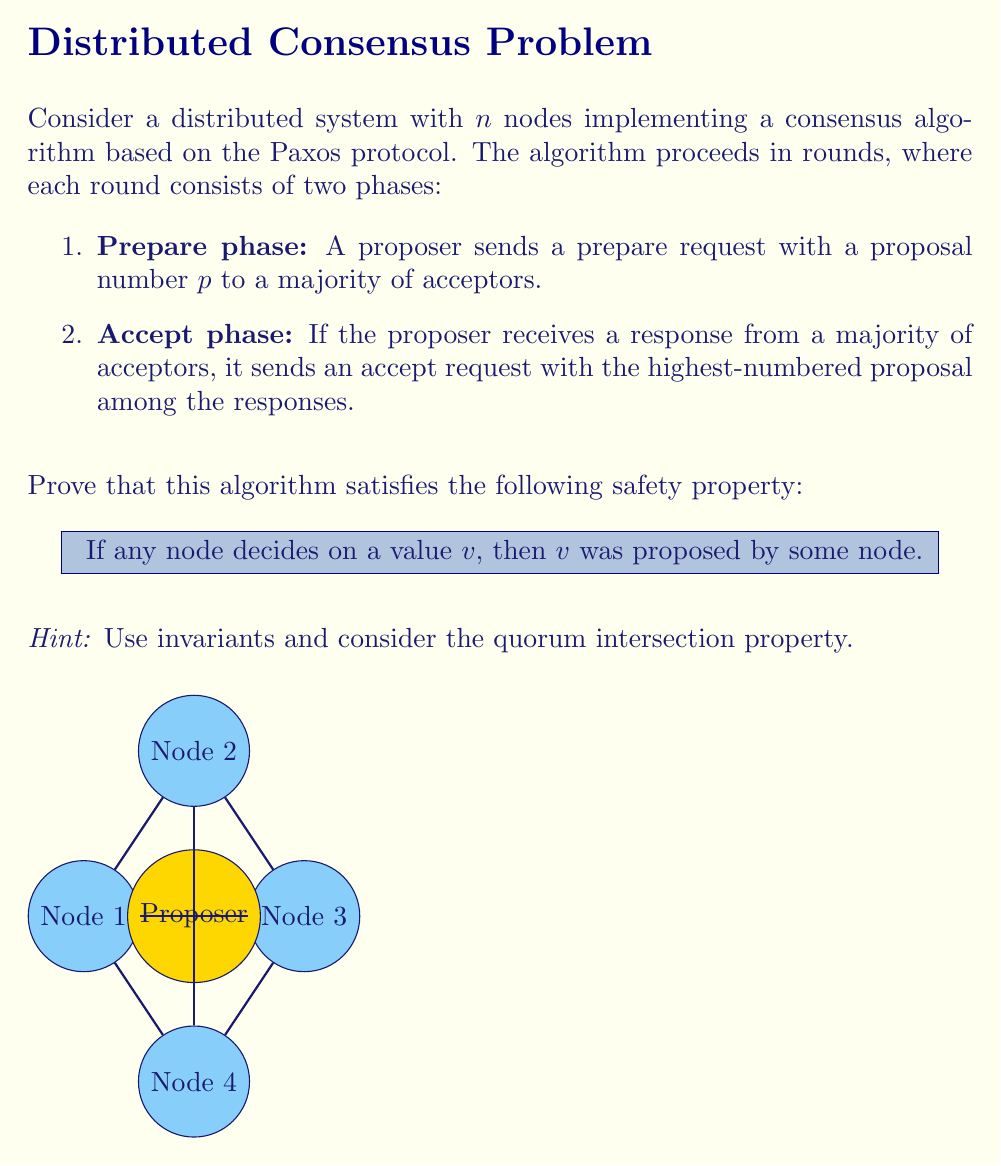Provide a solution to this math problem. To prove the safety property, we'll use invariants and the quorum intersection property. Let's proceed step-by-step:

1. Invariant: For any accept request with value $v$ sent in round $r$, $v$ was proposed by some node.

Proof of invariant:
a) In the prepare phase, the proposer collects responses from a majority of acceptors.
b) If any acceptor has previously accepted a value, the proposer must choose the value of the highest-numbered proposal among the responses.
c) If no acceptor has previously accepted a value, the proposer can choose any proposed value.
d) In both cases, the value in the accept request was either previously accepted (and thus proposed) or newly proposed.

2. Quorum Intersection Property: Any two majorities of nodes in the system must intersect.

Proof:
Let $Q_1$ and $Q_2$ be two majorities. 
$$|Q_1| > \frac{n}{2} \text{ and } |Q_2| > \frac{n}{2}$$
$$|Q_1| + |Q_2| > n$$
Therefore, $Q_1$ and $Q_2$ must have at least one node in common.

3. Proof of Safety Property:
a) Assume a node decides on a value $v$.
b) This means the node received accept requests with value $v$ from a majority of acceptors in some round $r$.
c) By the invariant, $v$ was proposed by some node for round $r$.
d) For any future round $r' > r$:
   - The prepare phase of $r'$ will intersect with the majority that accepted $v$ in round $r$ (by quorum intersection).
   - At least one acceptor in this intersection will report $v$ as the previously accepted value.
   - The proposer in $r'$ must either choose $v$ or a value from a higher-numbered proposal.
e) By induction, any value decided in a future round must have been proposed in that round or a previous round.

Therefore, if any node decides on a value $v$, then $v$ was proposed by some node.
Answer: The safety property holds due to the invariant that accept requests always contain proposed values, and the quorum intersection property ensures this invariant is maintained across rounds. 